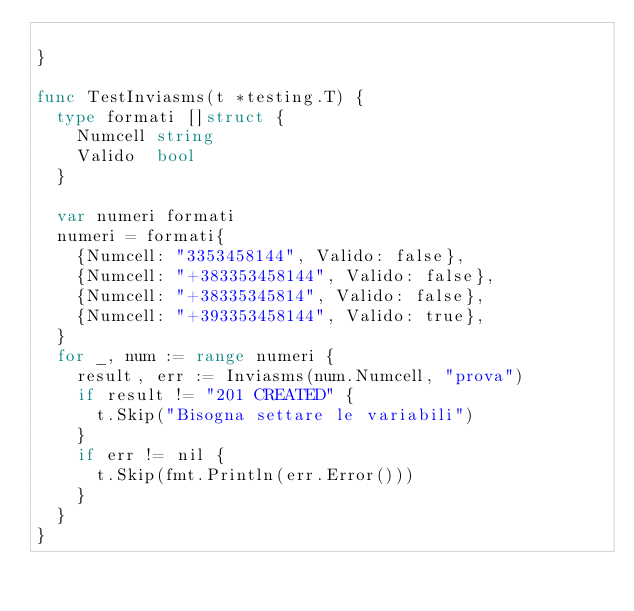Convert code to text. <code><loc_0><loc_0><loc_500><loc_500><_Go_>
}

func TestInviasms(t *testing.T) {
	type formati []struct {
		Numcell string
		Valido  bool
	}

	var numeri formati
	numeri = formati{
		{Numcell: "3353458144", Valido: false},
		{Numcell: "+383353458144", Valido: false},
		{Numcell: "+38335345814", Valido: false},
		{Numcell: "+393353458144", Valido: true},
	}
	for _, num := range numeri {
		result, err := Inviasms(num.Numcell, "prova")
		if result != "201 CREATED" {
			t.Skip("Bisogna settare le variabili")
		}
		if err != nil {
			t.Skip(fmt.Println(err.Error()))
		}
	}
}
</code> 